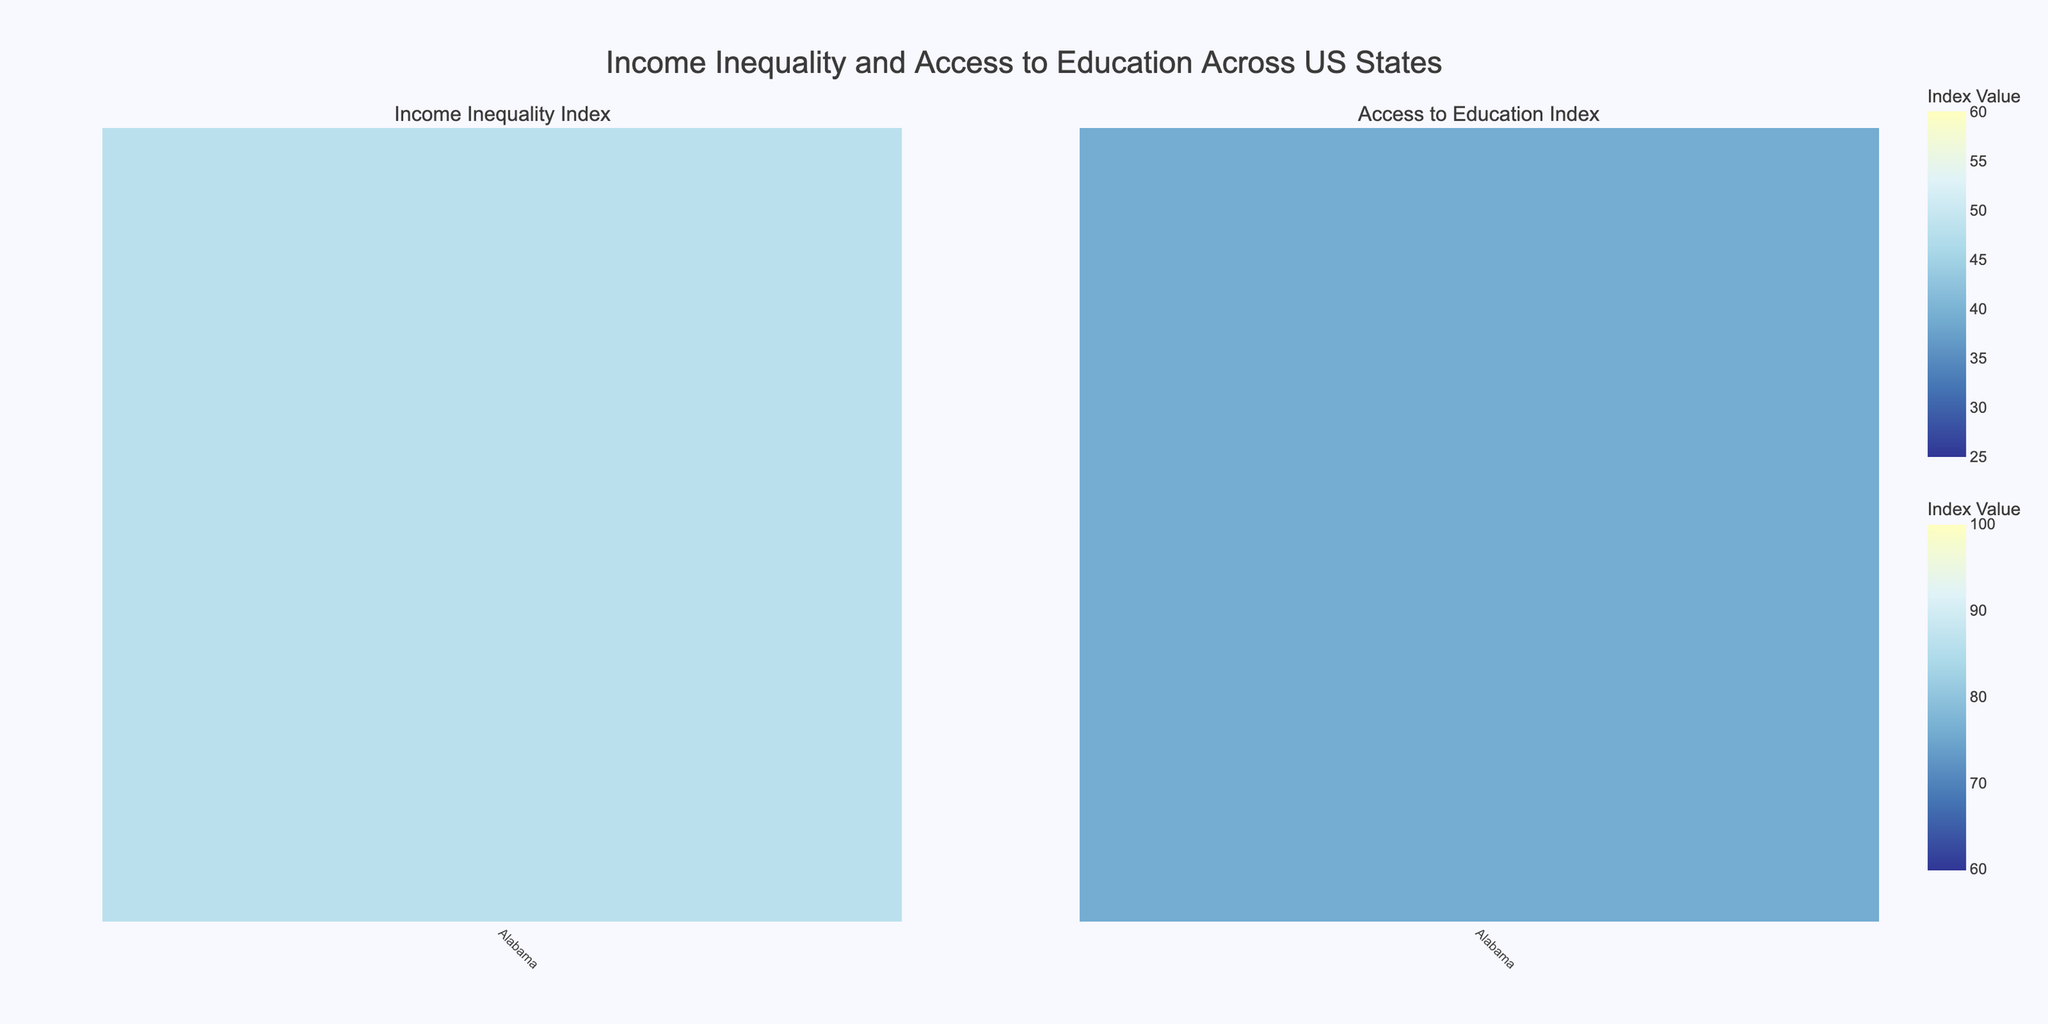How many states have data values displayed in both the Income Inequality Index and Access to Education Index heatmaps? There are two heatmaps displayed, each representing data for US states. By checking the x-axis labels on both heatmaps, we can see that all 50 US states are represented in both heatmaps.
Answer: 50 Which state has the highest Income Inequality Index? By examining the color intensity and the z-values across the states in the Income Inequality Index heatmap, Louisiana and New York show the highest values. We identify Louisiana with an index of 55.
Answer: Louisiana Which state has the lowest Access to Education Index? By examining the color intensity and the z-values across the states in the Access to Education Index heatmap, New Mexico has the lowest Access to Education Index value of 64.
Answer: New Mexico What is the difference between the Income Inequality Index of California and Alaska? From the heatmap, California shows an Income Inequality Index of 53, and Alaska has an index of 35. The difference is calculated as 53 - 35.
Answer: 18 Which states have both a high Income Inequality Index (greater than 50) and a high Access to Education Index (greater than 85)? By cross-referencing both heatmaps, identifying states with Income Inequality Index over 50 and Access to Education Index over 85 will lead us to California (53, 85), New Jersey (51, 92) and Illinois fits the criteria partially (51, 80).
Answer: California, New Jersey What overall pattern do you observe between Income Inequality Index and Access to Education Index? By comparing patterns on both heatmaps, generally states with higher Income Inequality Index tend to have a varied Access to Education Index. However, some states with lower Income Inequality Index have comparatively high Access to Education Index, suggesting no strong correlation.
Answer: No strong correlation What is the average Access to Education Index for states with an Income Inequality Index above 50? States with an Income Inequality Index above 50 are California (85), Illinois (80), New Jersey (92), Texas (70), New Mexico (64), New York (79), and Louisiana (65). The average is calculated by summing these values and dividing by the number of states: (85+80+92+70+64+79+65)/7.
Answer: 76.43 Which state has the biggest discrepancy between its Income Inequality Index and Access to Education Index? By cross-referencing the highest differences between the values in both heatmaps, we identify that Louisiana has an Income Inequality Index of 55 and Access to Education Index of 65, which displays the most considerable discrepancy of 55 - 65.
Answer: Louisiana Name the states with an Access to Education Index above 90 and the corresponding Income Inequality Index. From the Access to Education heatmap, states with an index above 90 are Connecticut (49), Colorado (39), Iowa (38), New Hampshire (29), Massachusetts (41), Oregon (37), New Jersey (51), Utah (30), Vermont (28), and Washington (40).
Answer: Connecticut (49), Colorado (39), Iowa (38), New Hampshire (29), Massachusetts (41), Oregon (37), New Jersey (51), Utah (30), Vermont (28), Washington (40) What is the range of the Income Inequality Index values across all states? The range is calculated by finding the difference between the maximum and minimum values in the Income Inequality Index, which are 55 (Louisiana) and 28 (Vermont). The range is 55 - 28.
Answer: 27 